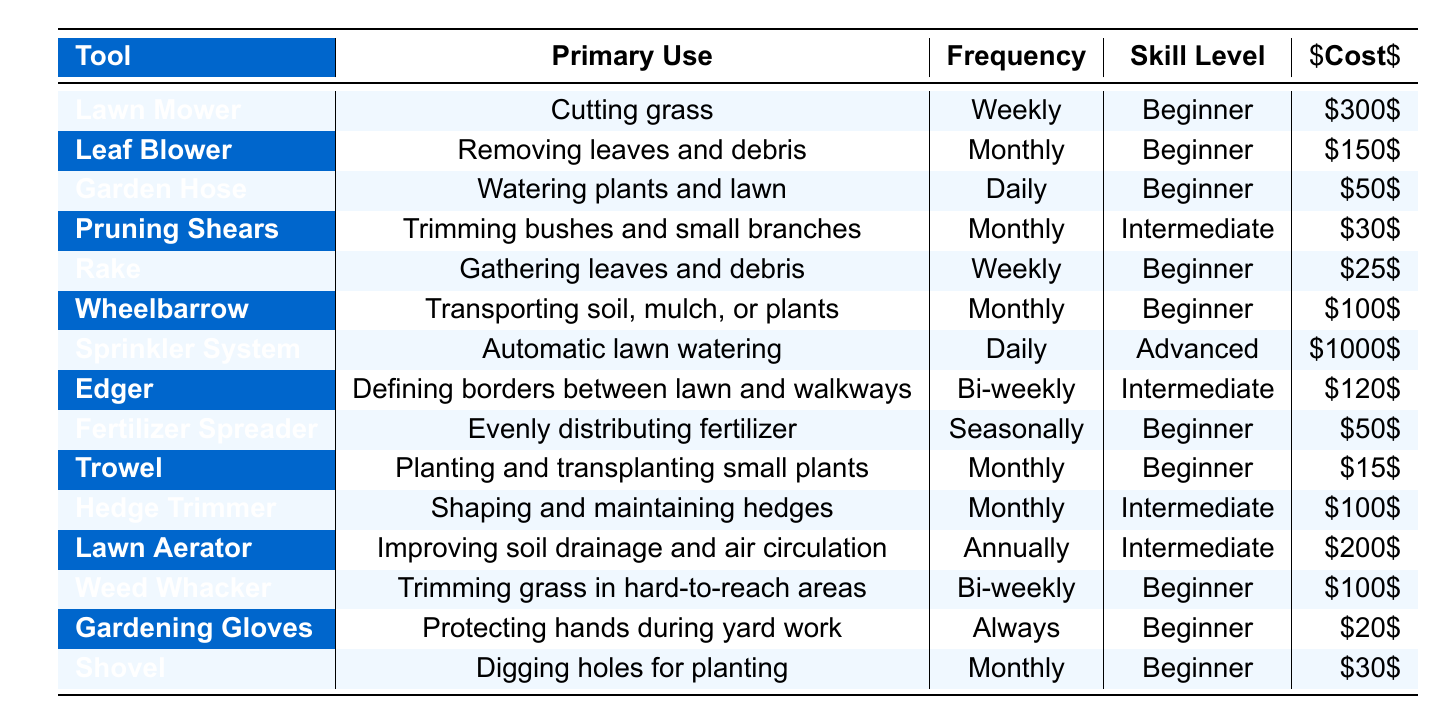What is the primary use of a lawn mower? The table lists "Cutting grass" as the primary use for a lawn mower in the respective row.
Answer: Cutting grass How much does a garden hose cost? The row for the garden hose shows an approximate cost of $50.
Answer: 50 Which tool requires the highest skill level? The sprinkler system is marked as requiring an "Advanced" skill level, which is the highest listed.
Answer: Sprinkler System How often is a rake used? According to the table, a rake is used weekly, as shown in its corresponding row.
Answer: Weekly Which tools are used daily? The table indicates that both the garden hose and the sprinkler system are used daily.
Answer: Garden Hose, Sprinkler System What is the average cost of all the beginner tools? To find this, we sum the costs of the beginner tools: Lawn Mower (300) + Leaf Blower (150) + Garden Hose (50) + Rake (25) + Wheelbarrow (100) + Fertilizer Spreader (50) + Trowel (15) + Weed Whacker (100) + Gardening Gloves (20) + Shovel (30) = 840. There are 10 beginner tools, so the average cost is 840/10 = 84.
Answer: 84 Does a hedge trimmer require a beginner skill level? A hedge trimmer is listed with an "Intermediate" skill level, so it does not require a beginner level of skill.
Answer: No Which tool has the lowest frequency of use? The lawn aerator is indicated to be used annually, which is less frequent than any other tool.
Answer: Lawn Aerator What is the total cost of all the tools listed? Adding the costs gives: 300 + 150 + 50 + 30 + 25 + 100 + 1000 + 120 + 50 + 15 + 100 + 200 + 100 + 20 + 30 = 2070.
Answer: 2070 How many tools can be used to protect hands during yard work? The only tool mentioned for protecting hands is gardening gloves, indicating there is one such tool.
Answer: 1 